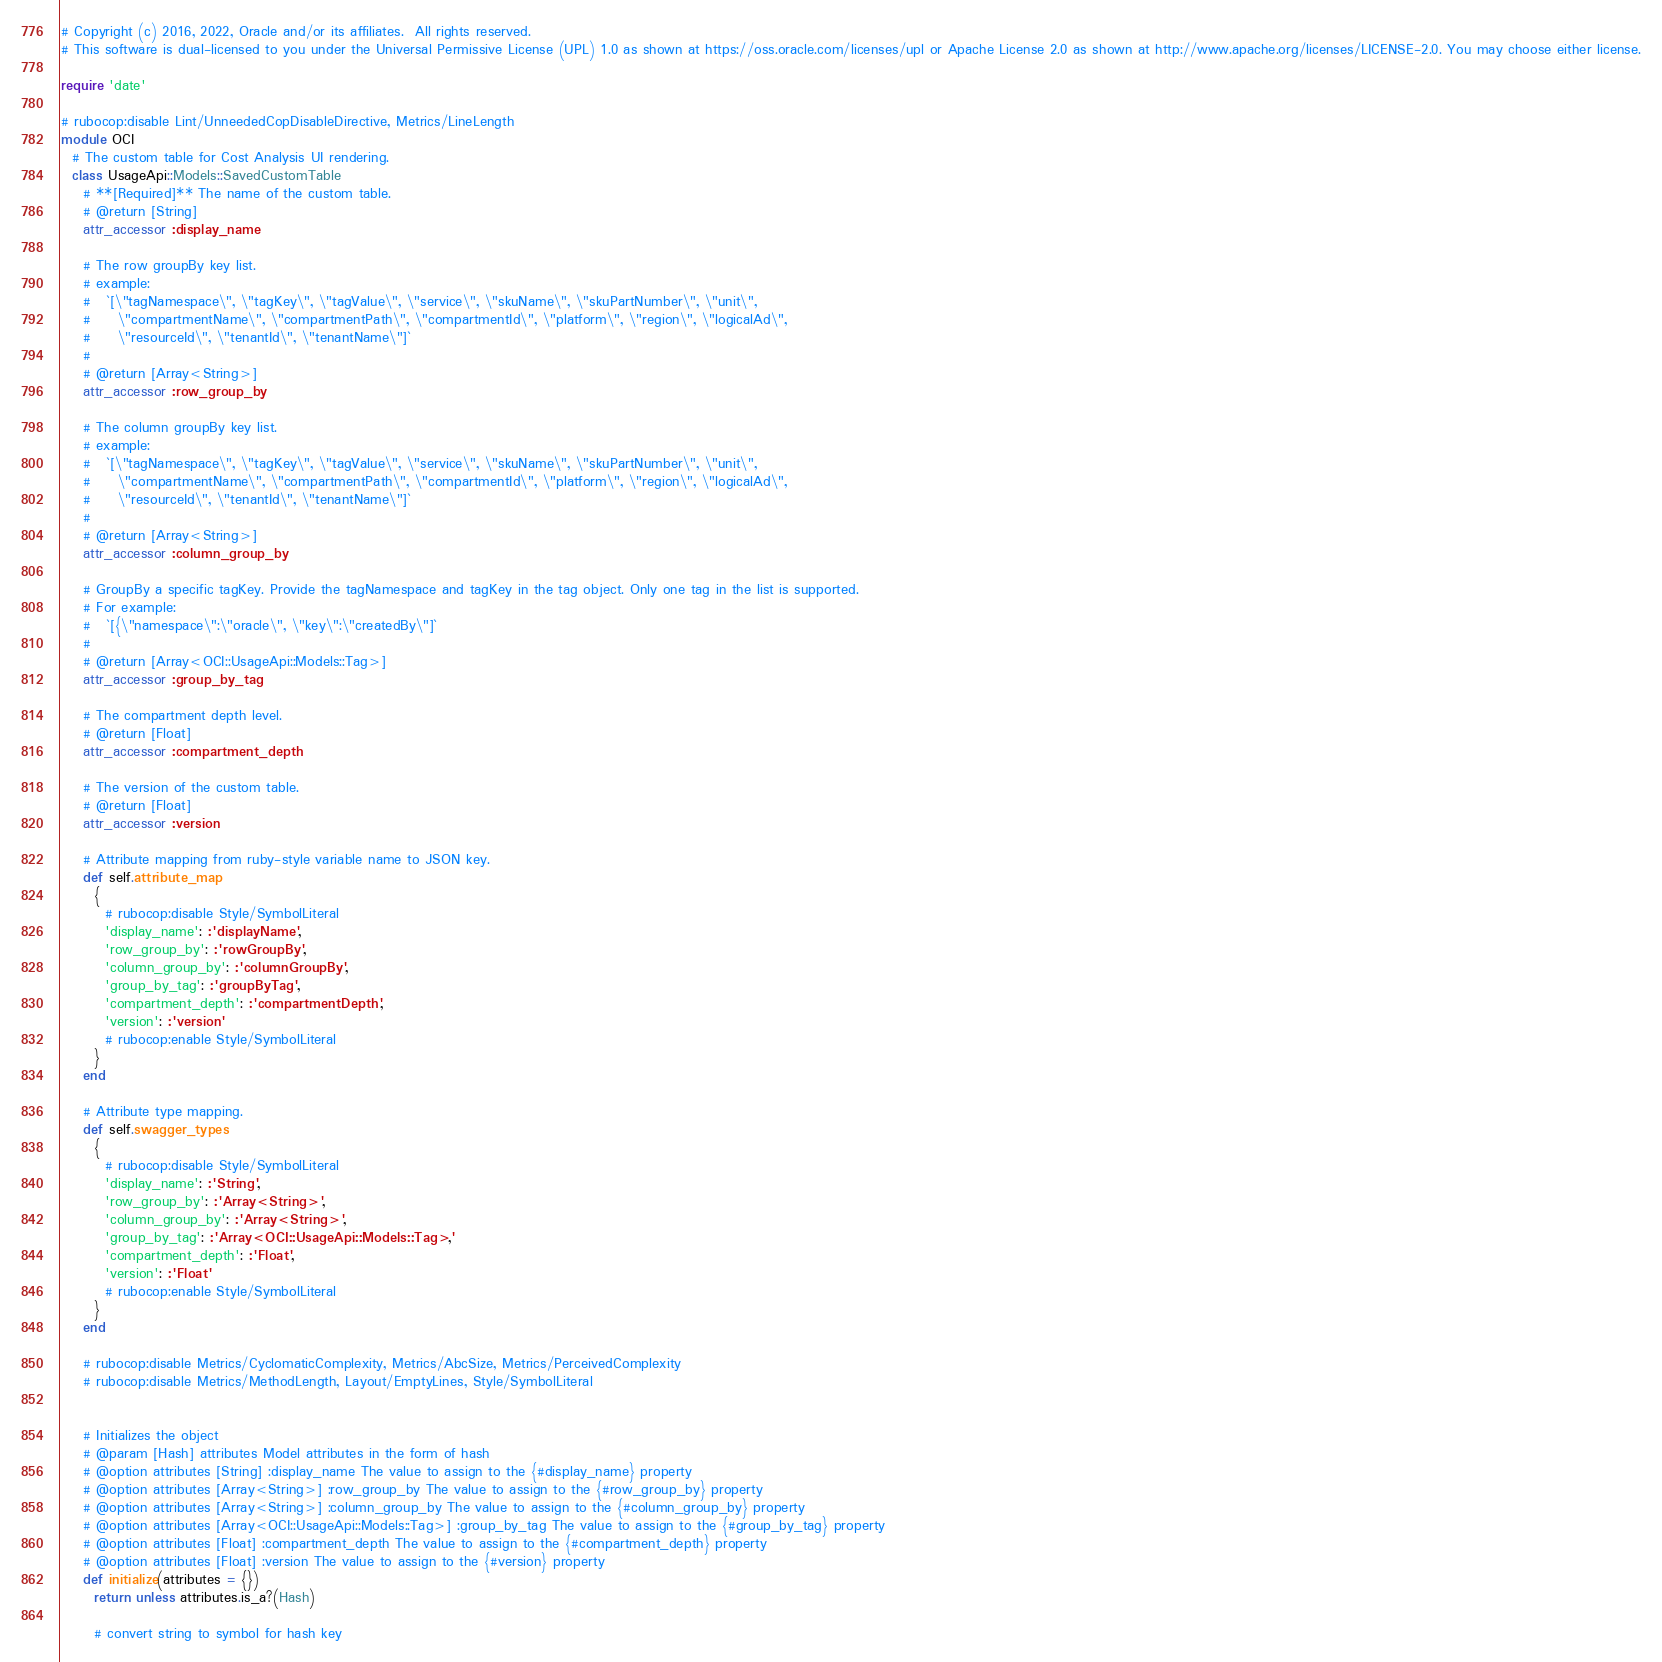<code> <loc_0><loc_0><loc_500><loc_500><_Ruby_># Copyright (c) 2016, 2022, Oracle and/or its affiliates.  All rights reserved.
# This software is dual-licensed to you under the Universal Permissive License (UPL) 1.0 as shown at https://oss.oracle.com/licenses/upl or Apache License 2.0 as shown at http://www.apache.org/licenses/LICENSE-2.0. You may choose either license.

require 'date'

# rubocop:disable Lint/UnneededCopDisableDirective, Metrics/LineLength
module OCI
  # The custom table for Cost Analysis UI rendering.
  class UsageApi::Models::SavedCustomTable
    # **[Required]** The name of the custom table.
    # @return [String]
    attr_accessor :display_name

    # The row groupBy key list.
    # example:
    #   `[\"tagNamespace\", \"tagKey\", \"tagValue\", \"service\", \"skuName\", \"skuPartNumber\", \"unit\",
    #     \"compartmentName\", \"compartmentPath\", \"compartmentId\", \"platform\", \"region\", \"logicalAd\",
    #     \"resourceId\", \"tenantId\", \"tenantName\"]`
    #
    # @return [Array<String>]
    attr_accessor :row_group_by

    # The column groupBy key list.
    # example:
    #   `[\"tagNamespace\", \"tagKey\", \"tagValue\", \"service\", \"skuName\", \"skuPartNumber\", \"unit\",
    #     \"compartmentName\", \"compartmentPath\", \"compartmentId\", \"platform\", \"region\", \"logicalAd\",
    #     \"resourceId\", \"tenantId\", \"tenantName\"]`
    #
    # @return [Array<String>]
    attr_accessor :column_group_by

    # GroupBy a specific tagKey. Provide the tagNamespace and tagKey in the tag object. Only one tag in the list is supported.
    # For example:
    #   `[{\"namespace\":\"oracle\", \"key\":\"createdBy\"]`
    #
    # @return [Array<OCI::UsageApi::Models::Tag>]
    attr_accessor :group_by_tag

    # The compartment depth level.
    # @return [Float]
    attr_accessor :compartment_depth

    # The version of the custom table.
    # @return [Float]
    attr_accessor :version

    # Attribute mapping from ruby-style variable name to JSON key.
    def self.attribute_map
      {
        # rubocop:disable Style/SymbolLiteral
        'display_name': :'displayName',
        'row_group_by': :'rowGroupBy',
        'column_group_by': :'columnGroupBy',
        'group_by_tag': :'groupByTag',
        'compartment_depth': :'compartmentDepth',
        'version': :'version'
        # rubocop:enable Style/SymbolLiteral
      }
    end

    # Attribute type mapping.
    def self.swagger_types
      {
        # rubocop:disable Style/SymbolLiteral
        'display_name': :'String',
        'row_group_by': :'Array<String>',
        'column_group_by': :'Array<String>',
        'group_by_tag': :'Array<OCI::UsageApi::Models::Tag>',
        'compartment_depth': :'Float',
        'version': :'Float'
        # rubocop:enable Style/SymbolLiteral
      }
    end

    # rubocop:disable Metrics/CyclomaticComplexity, Metrics/AbcSize, Metrics/PerceivedComplexity
    # rubocop:disable Metrics/MethodLength, Layout/EmptyLines, Style/SymbolLiteral


    # Initializes the object
    # @param [Hash] attributes Model attributes in the form of hash
    # @option attributes [String] :display_name The value to assign to the {#display_name} property
    # @option attributes [Array<String>] :row_group_by The value to assign to the {#row_group_by} property
    # @option attributes [Array<String>] :column_group_by The value to assign to the {#column_group_by} property
    # @option attributes [Array<OCI::UsageApi::Models::Tag>] :group_by_tag The value to assign to the {#group_by_tag} property
    # @option attributes [Float] :compartment_depth The value to assign to the {#compartment_depth} property
    # @option attributes [Float] :version The value to assign to the {#version} property
    def initialize(attributes = {})
      return unless attributes.is_a?(Hash)

      # convert string to symbol for hash key</code> 